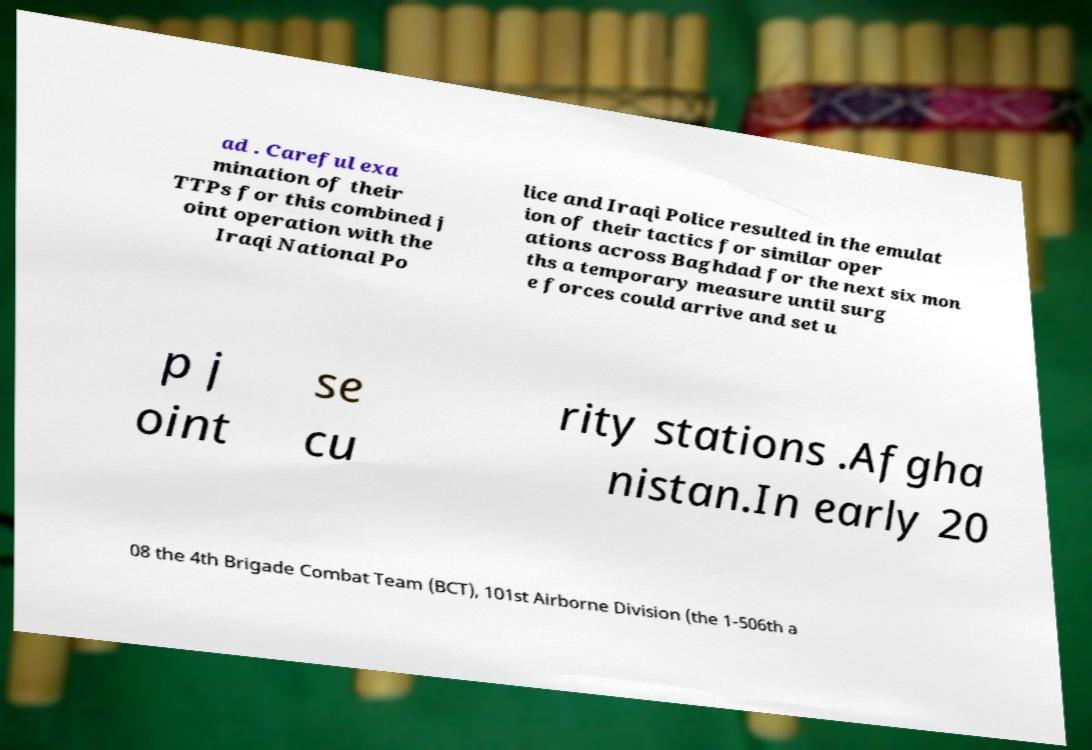Can you read and provide the text displayed in the image?This photo seems to have some interesting text. Can you extract and type it out for me? ad . Careful exa mination of their TTPs for this combined j oint operation with the Iraqi National Po lice and Iraqi Police resulted in the emulat ion of their tactics for similar oper ations across Baghdad for the next six mon ths a temporary measure until surg e forces could arrive and set u p j oint se cu rity stations .Afgha nistan.In early 20 08 the 4th Brigade Combat Team (BCT), 101st Airborne Division (the 1-506th a 